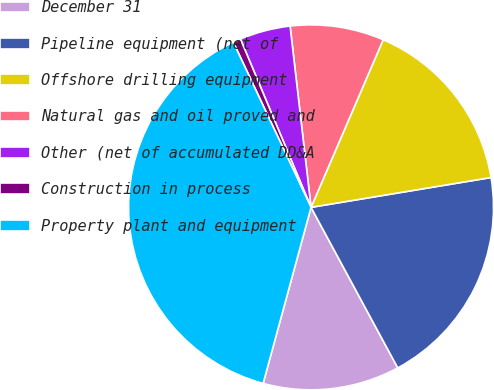Convert chart to OTSL. <chart><loc_0><loc_0><loc_500><loc_500><pie_chart><fcel>December 31<fcel>Pipeline equipment (net of<fcel>Offshore drilling equipment<fcel>Natural gas and oil proved and<fcel>Other (net of accumulated DD&A<fcel>Construction in process<fcel>Property plant and equipment<nl><fcel>12.11%<fcel>19.73%<fcel>15.92%<fcel>8.3%<fcel>4.49%<fcel>0.68%<fcel>38.77%<nl></chart> 